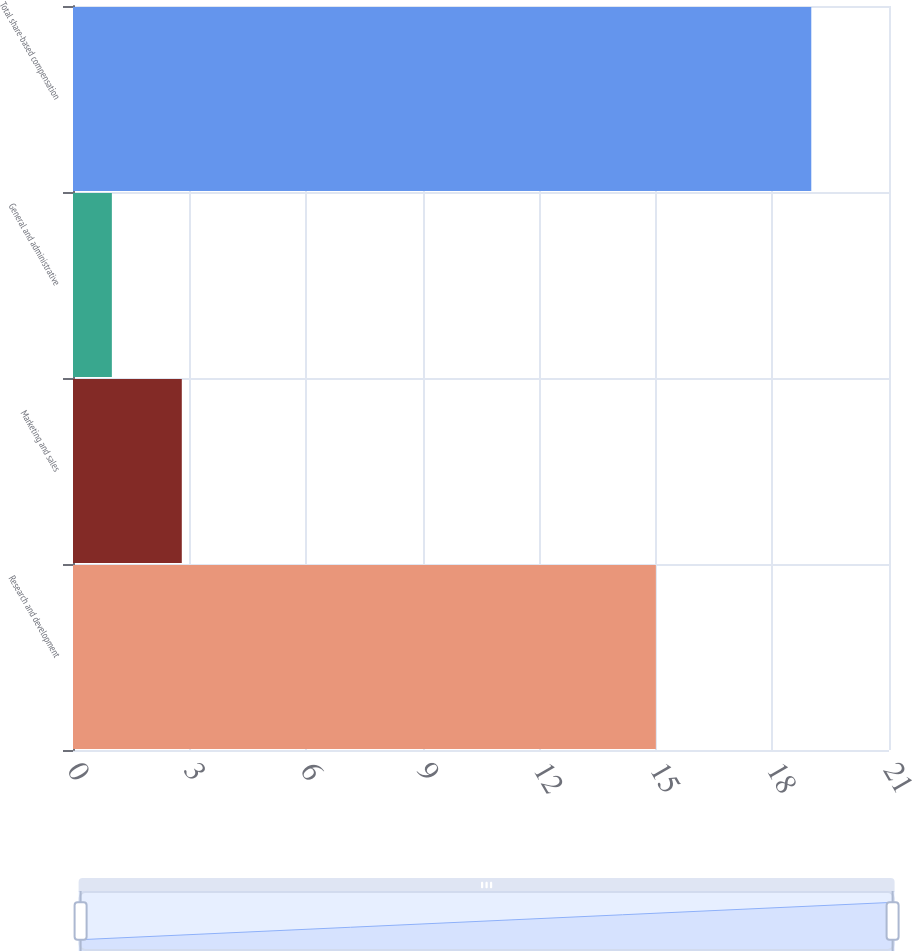Convert chart. <chart><loc_0><loc_0><loc_500><loc_500><bar_chart><fcel>Research and development<fcel>Marketing and sales<fcel>General and administrative<fcel>Total share-based compensation<nl><fcel>15<fcel>2.8<fcel>1<fcel>19<nl></chart> 